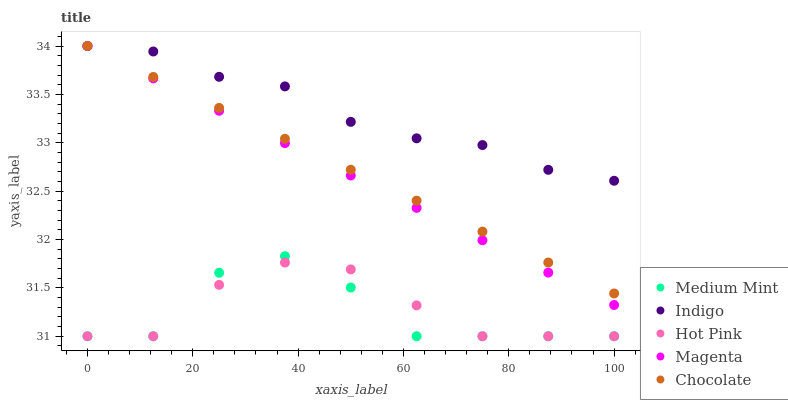Does Medium Mint have the minimum area under the curve?
Answer yes or no. Yes. Does Indigo have the maximum area under the curve?
Answer yes or no. Yes. Does Magenta have the minimum area under the curve?
Answer yes or no. No. Does Magenta have the maximum area under the curve?
Answer yes or no. No. Is Magenta the smoothest?
Answer yes or no. Yes. Is Medium Mint the roughest?
Answer yes or no. Yes. Is Hot Pink the smoothest?
Answer yes or no. No. Is Hot Pink the roughest?
Answer yes or no. No. Does Medium Mint have the lowest value?
Answer yes or no. Yes. Does Magenta have the lowest value?
Answer yes or no. No. Does Chocolate have the highest value?
Answer yes or no. Yes. Does Hot Pink have the highest value?
Answer yes or no. No. Is Hot Pink less than Indigo?
Answer yes or no. Yes. Is Magenta greater than Hot Pink?
Answer yes or no. Yes. Does Chocolate intersect Indigo?
Answer yes or no. Yes. Is Chocolate less than Indigo?
Answer yes or no. No. Is Chocolate greater than Indigo?
Answer yes or no. No. Does Hot Pink intersect Indigo?
Answer yes or no. No. 